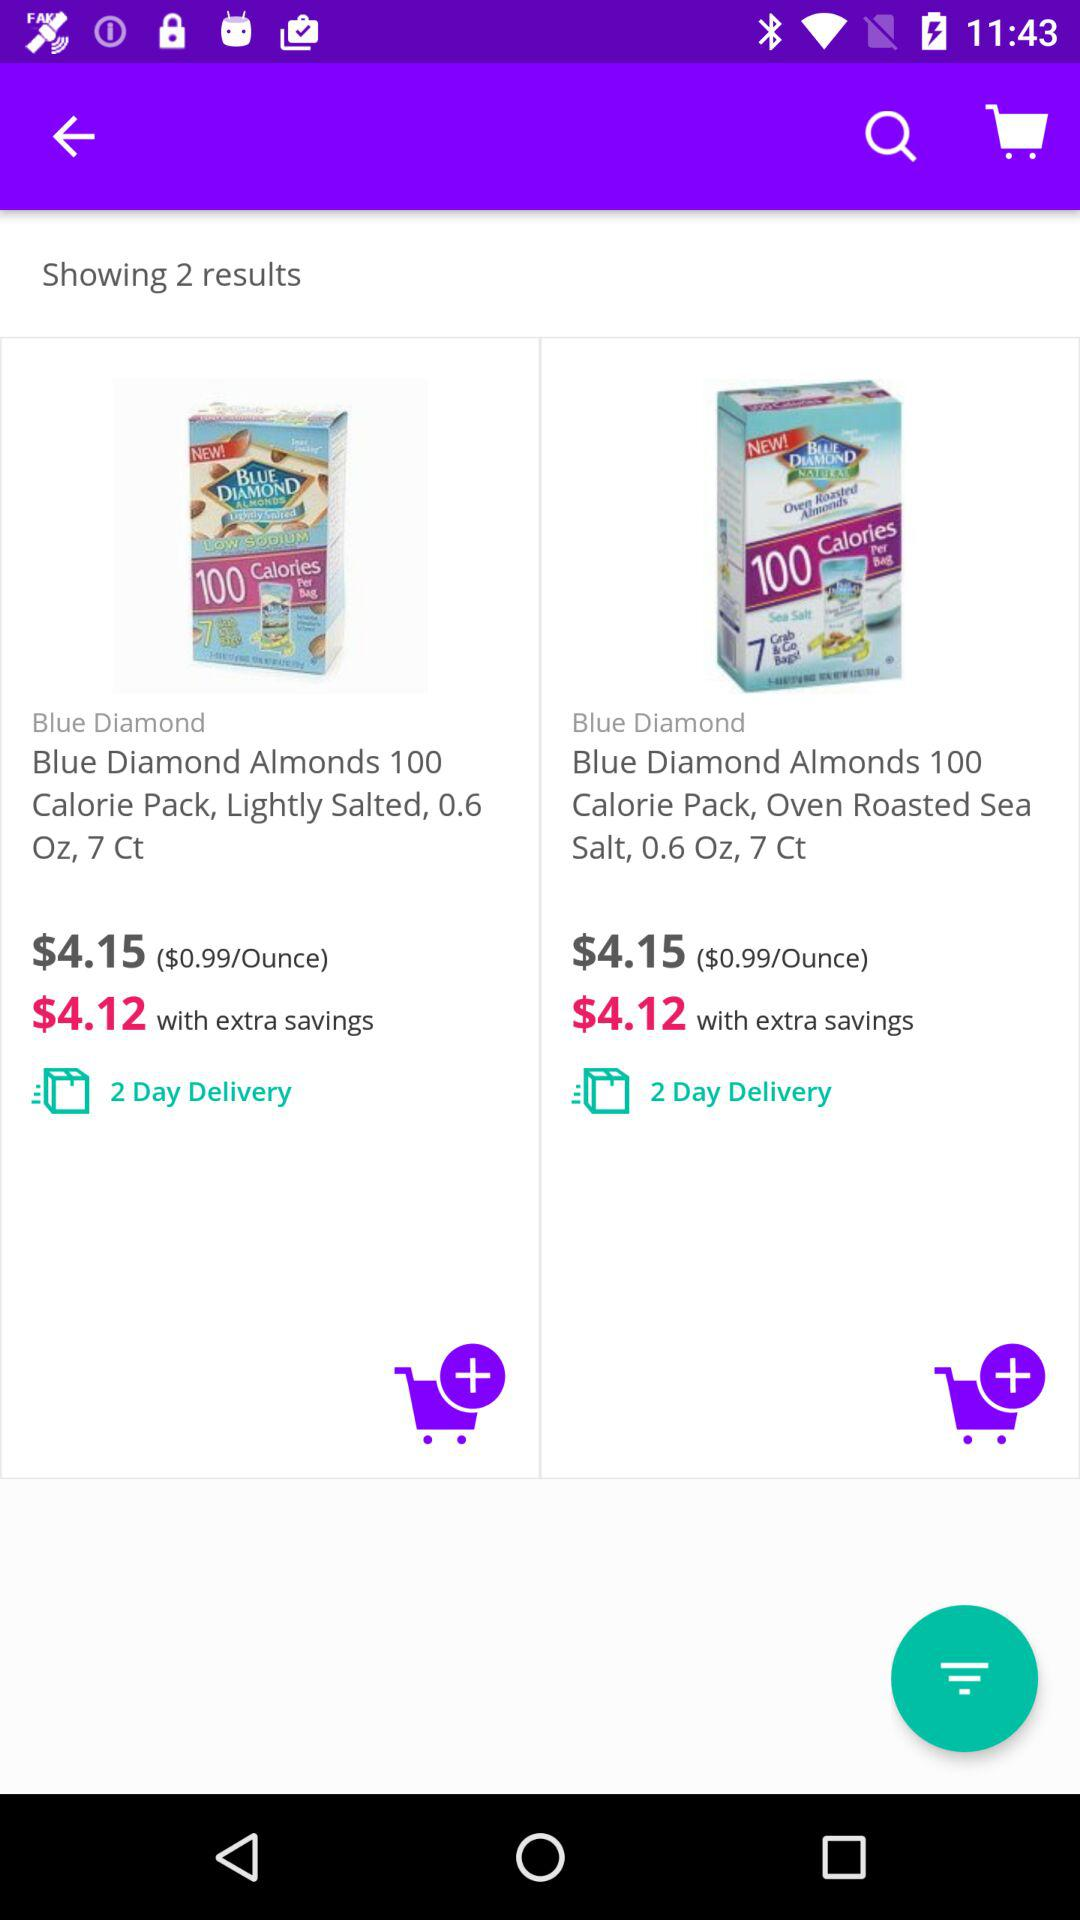How many items are in the search results?
Answer the question using a single word or phrase. 2 